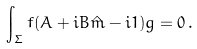<formula> <loc_0><loc_0><loc_500><loc_500>\int _ { \Sigma } f ( A + i B \hat { m } - i { 1 } ) g = 0 \, .</formula> 